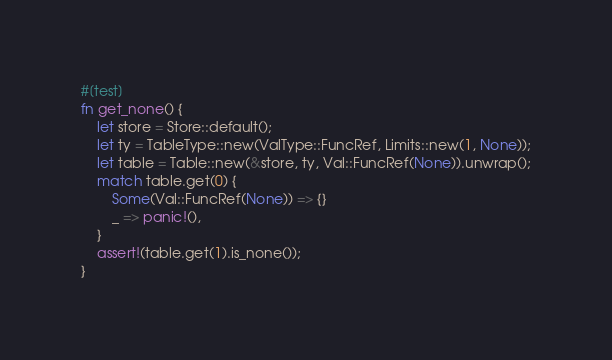Convert code to text. <code><loc_0><loc_0><loc_500><loc_500><_Rust_>#[test]
fn get_none() {
    let store = Store::default();
    let ty = TableType::new(ValType::FuncRef, Limits::new(1, None));
    let table = Table::new(&store, ty, Val::FuncRef(None)).unwrap();
    match table.get(0) {
        Some(Val::FuncRef(None)) => {}
        _ => panic!(),
    }
    assert!(table.get(1).is_none());
}
</code> 